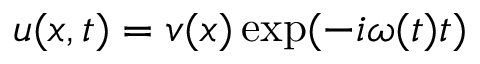<formula> <loc_0><loc_0><loc_500><loc_500>u ( x , t ) = v ( x ) \exp ( - i \omega ( t ) t )</formula> 